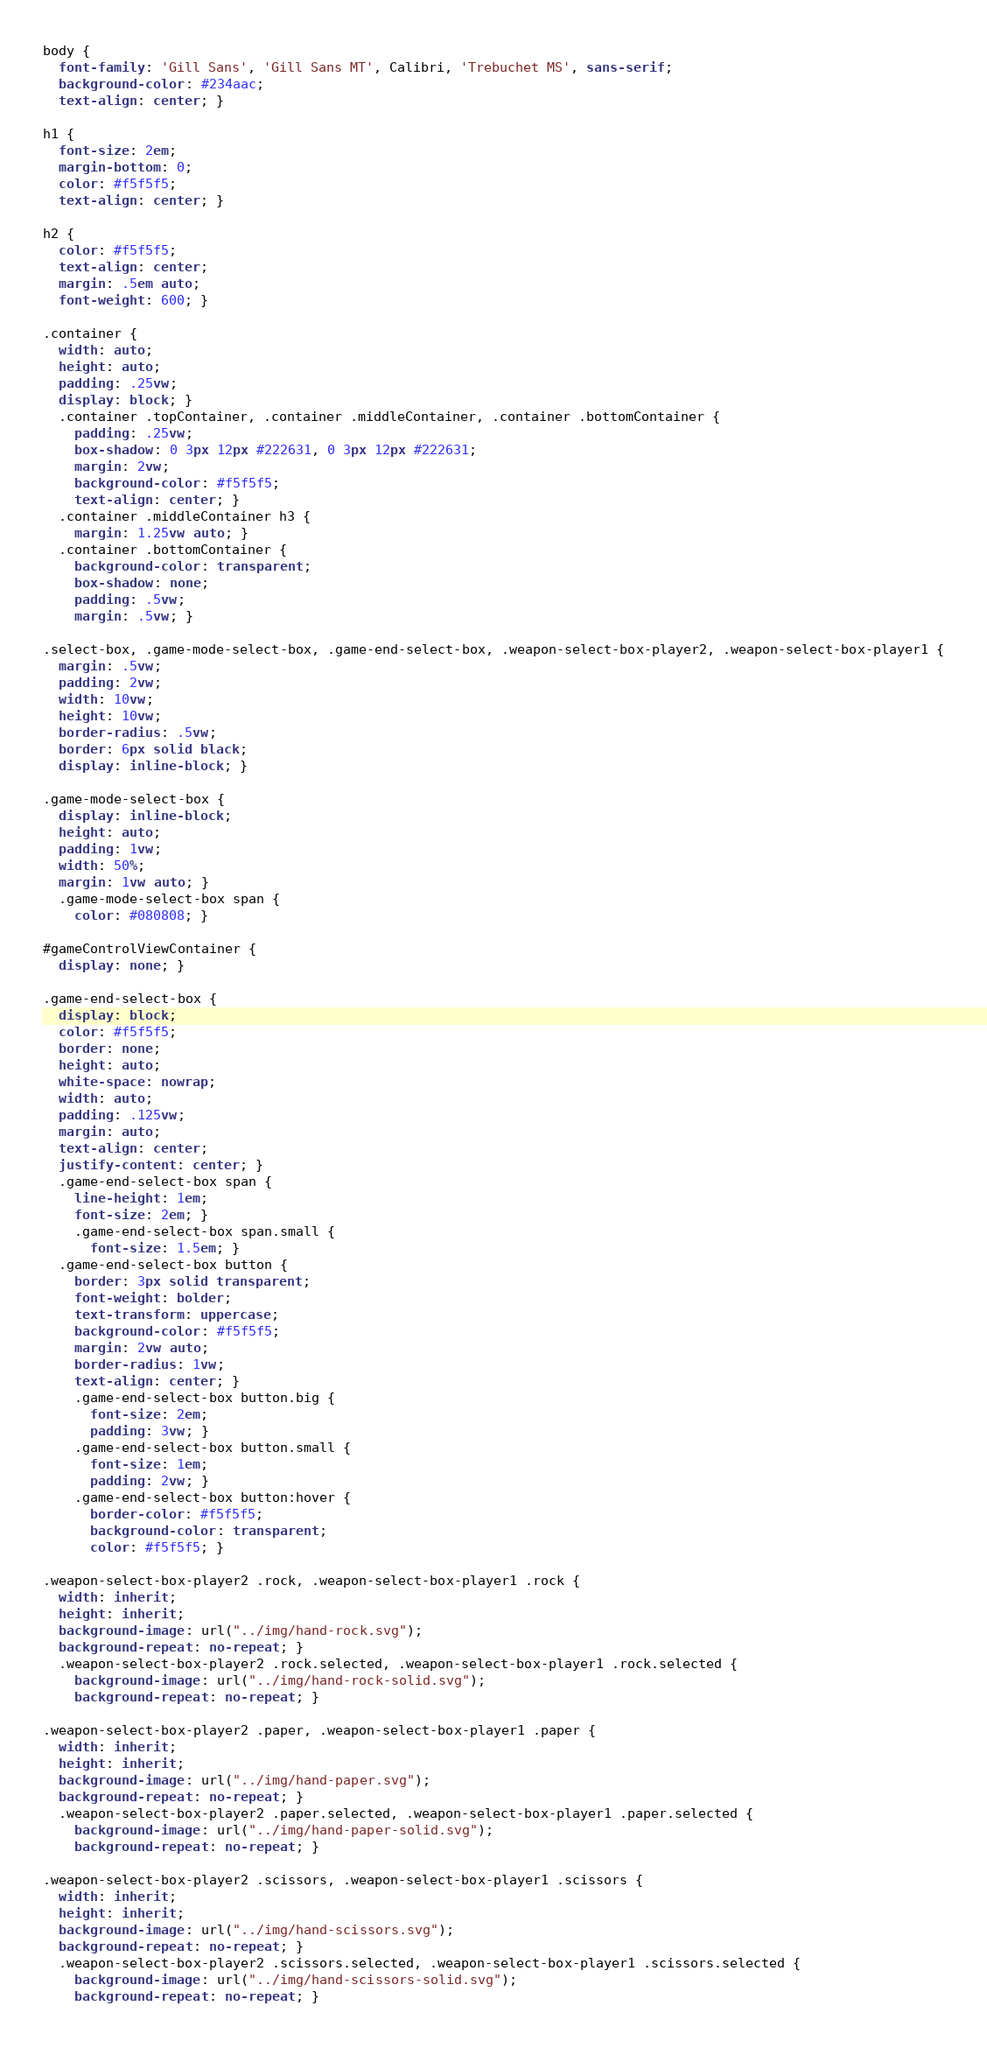<code> <loc_0><loc_0><loc_500><loc_500><_CSS_>body {
  font-family: 'Gill Sans', 'Gill Sans MT', Calibri, 'Trebuchet MS', sans-serif;
  background-color: #234aac;
  text-align: center; }

h1 {
  font-size: 2em;
  margin-bottom: 0;
  color: #f5f5f5;
  text-align: center; }

h2 {
  color: #f5f5f5;
  text-align: center;
  margin: .5em auto;
  font-weight: 600; }

.container {
  width: auto;
  height: auto;
  padding: .25vw;
  display: block; }
  .container .topContainer, .container .middleContainer, .container .bottomContainer {
    padding: .25vw;
    box-shadow: 0 3px 12px #222631, 0 3px 12px #222631;
    margin: 2vw;
    background-color: #f5f5f5;
    text-align: center; }
  .container .middleContainer h3 {
    margin: 1.25vw auto; }
  .container .bottomContainer {
    background-color: transparent;
    box-shadow: none;
    padding: .5vw;
    margin: .5vw; }

.select-box, .game-mode-select-box, .game-end-select-box, .weapon-select-box-player2, .weapon-select-box-player1 {
  margin: .5vw;
  padding: 2vw;
  width: 10vw;
  height: 10vw;
  border-radius: .5vw;
  border: 6px solid black;
  display: inline-block; }

.game-mode-select-box {
  display: inline-block;
  height: auto;
  padding: 1vw;
  width: 50%;
  margin: 1vw auto; }
  .game-mode-select-box span {
    color: #080808; }

#gameControlViewContainer {
  display: none; }

.game-end-select-box {
  display: block;
  color: #f5f5f5;
  border: none;
  height: auto;
  white-space: nowrap;
  width: auto;
  padding: .125vw;
  margin: auto;
  text-align: center;
  justify-content: center; }
  .game-end-select-box span {
    line-height: 1em;
    font-size: 2em; }
    .game-end-select-box span.small {
      font-size: 1.5em; }
  .game-end-select-box button {
    border: 3px solid transparent;
    font-weight: bolder;
    text-transform: uppercase;
    background-color: #f5f5f5;
    margin: 2vw auto;
    border-radius: 1vw;
    text-align: center; }
    .game-end-select-box button.big {
      font-size: 2em;
      padding: 3vw; }
    .game-end-select-box button.small {
      font-size: 1em;
      padding: 2vw; }
    .game-end-select-box button:hover {
      border-color: #f5f5f5;
      background-color: transparent;
      color: #f5f5f5; }

.weapon-select-box-player2 .rock, .weapon-select-box-player1 .rock {
  width: inherit;
  height: inherit;
  background-image: url("../img/hand-rock.svg");
  background-repeat: no-repeat; }
  .weapon-select-box-player2 .rock.selected, .weapon-select-box-player1 .rock.selected {
    background-image: url("../img/hand-rock-solid.svg");
    background-repeat: no-repeat; }

.weapon-select-box-player2 .paper, .weapon-select-box-player1 .paper {
  width: inherit;
  height: inherit;
  background-image: url("../img/hand-paper.svg");
  background-repeat: no-repeat; }
  .weapon-select-box-player2 .paper.selected, .weapon-select-box-player1 .paper.selected {
    background-image: url("../img/hand-paper-solid.svg");
    background-repeat: no-repeat; }

.weapon-select-box-player2 .scissors, .weapon-select-box-player1 .scissors {
  width: inherit;
  height: inherit;
  background-image: url("../img/hand-scissors.svg");
  background-repeat: no-repeat; }
  .weapon-select-box-player2 .scissors.selected, .weapon-select-box-player1 .scissors.selected {
    background-image: url("../img/hand-scissors-solid.svg");
    background-repeat: no-repeat; }
</code> 